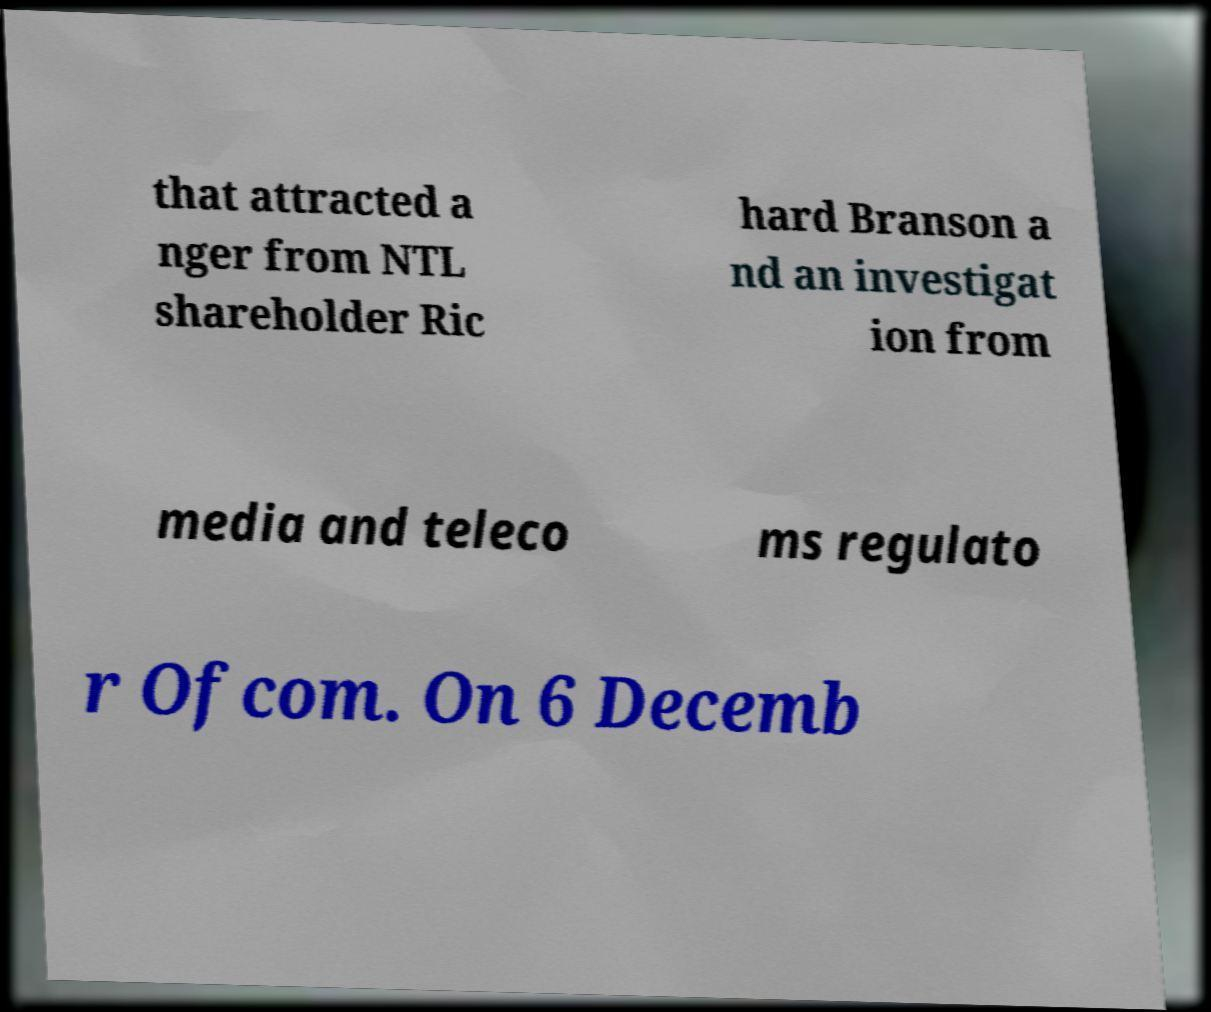Could you extract and type out the text from this image? that attracted a nger from NTL shareholder Ric hard Branson a nd an investigat ion from media and teleco ms regulato r Ofcom. On 6 Decemb 